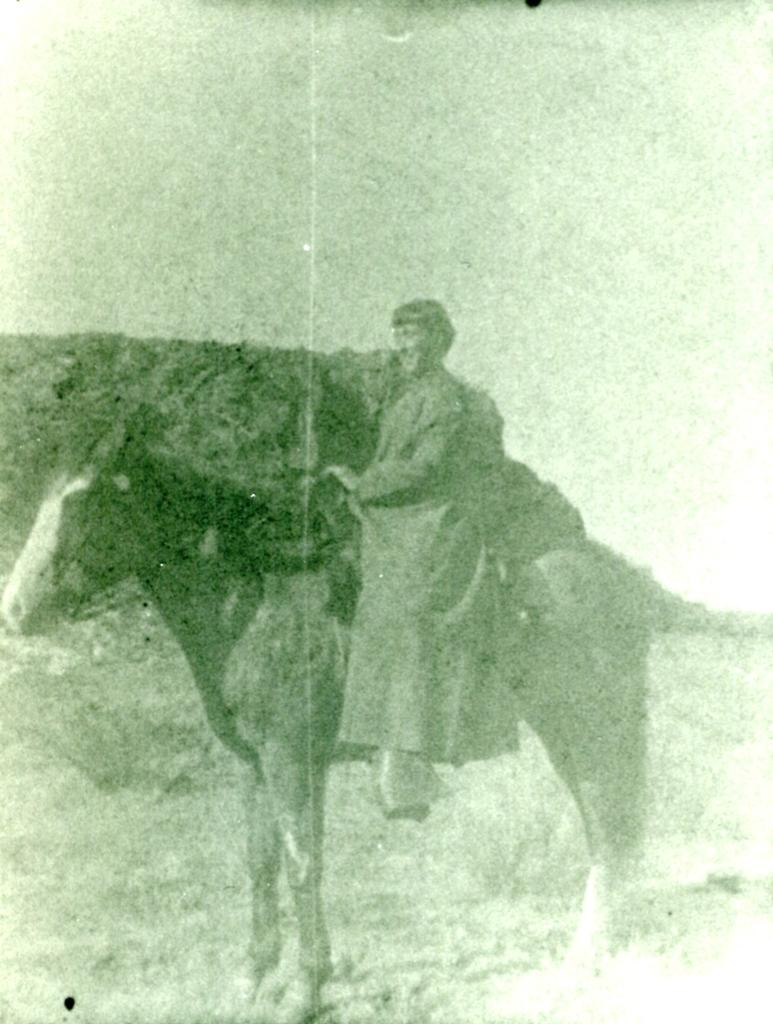Who or what is the main subject in the image? There is a person in the image. What is the person doing in the image? The person is on the back of a horse. What is the color scheme of the image? The image is in black and white. What can be seen in the distance in the image? There are mountains in the background of the image. What type of trousers is the crowd wearing in the image? There is no crowd present in the image, and therefore no trousers can be observed. What kind of bait is being used to attract the fish in the image? There is no fishing or bait present in the image; it features a person on a horse with mountains in the background. 